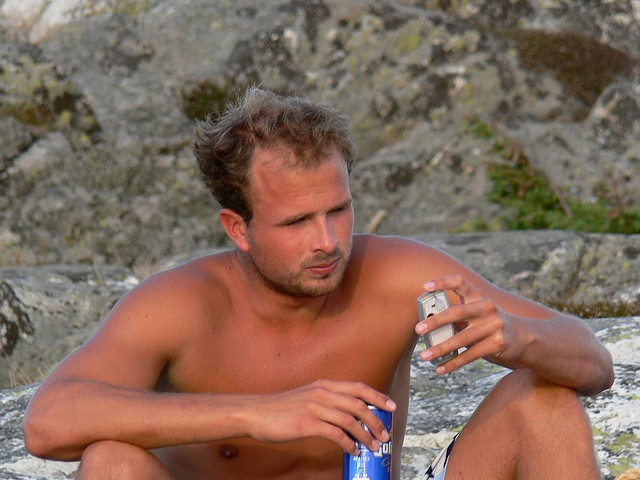Describe the objects in this image and their specific colors. I can see people in gray, brown, salmon, and maroon tones, cup in gray, navy, lightblue, darkblue, and lightgray tones, and cell phone in gray, darkgray, and lightgray tones in this image. 